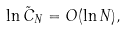Convert formula to latex. <formula><loc_0><loc_0><loc_500><loc_500>\ln \tilde { C } _ { N } = O ( \ln N ) ,</formula> 